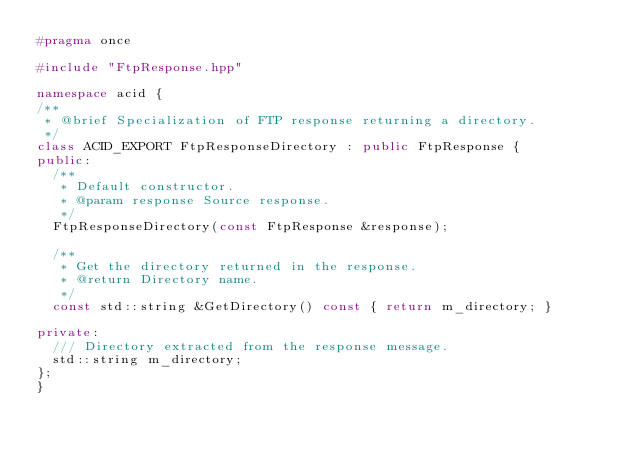Convert code to text. <code><loc_0><loc_0><loc_500><loc_500><_C++_>#pragma once

#include "FtpResponse.hpp"

namespace acid {
/**
 * @brief Specialization of FTP response returning a directory.
 */
class ACID_EXPORT FtpResponseDirectory : public FtpResponse {
public:
	/**
	 * Default constructor.
	 * @param response Source response.
	 */
	FtpResponseDirectory(const FtpResponse &response);

	/**
	 * Get the directory returned in the response.
	 * @return Directory name.
	 */
	const std::string &GetDirectory() const { return m_directory; }

private:
	/// Directory extracted from the response message.
	std::string m_directory;
};
}
</code> 